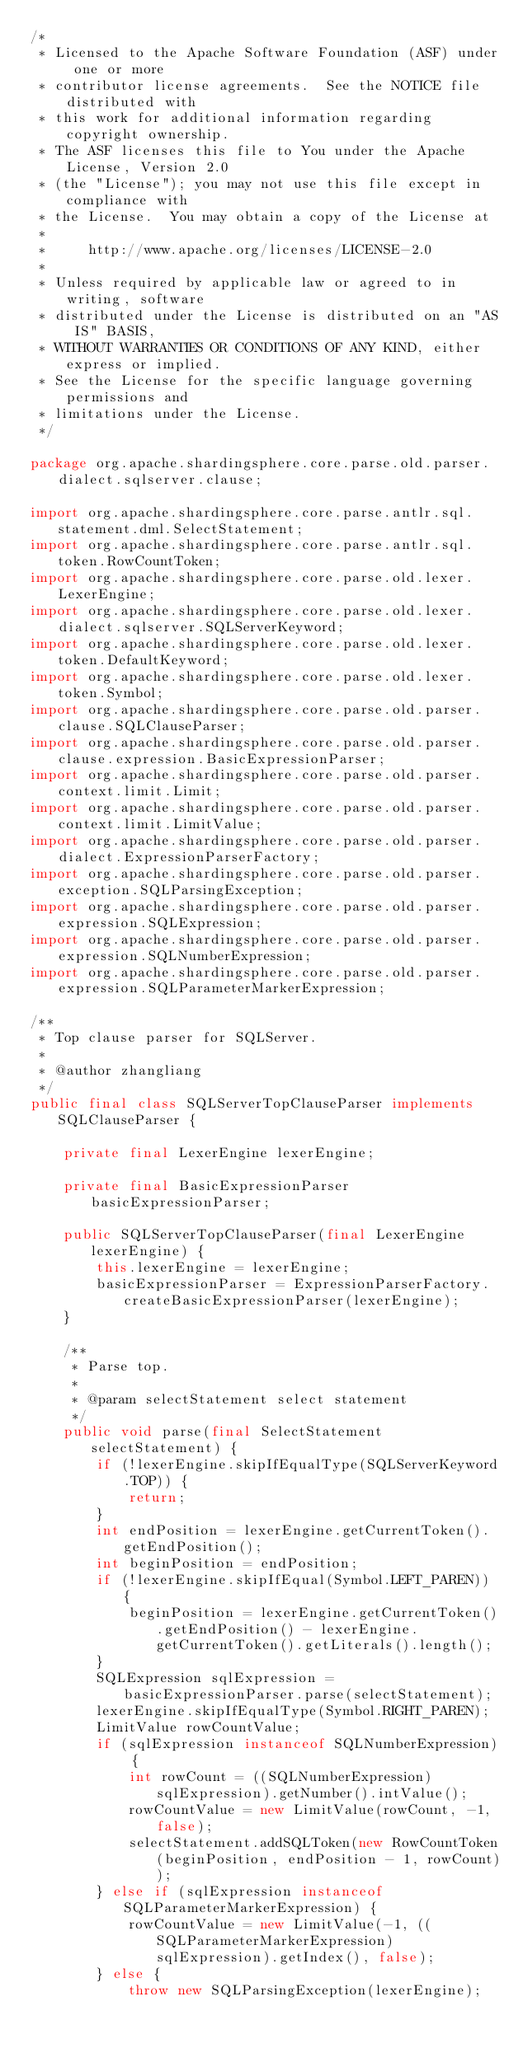Convert code to text. <code><loc_0><loc_0><loc_500><loc_500><_Java_>/*
 * Licensed to the Apache Software Foundation (ASF) under one or more
 * contributor license agreements.  See the NOTICE file distributed with
 * this work for additional information regarding copyright ownership.
 * The ASF licenses this file to You under the Apache License, Version 2.0
 * (the "License"); you may not use this file except in compliance with
 * the License.  You may obtain a copy of the License at
 *
 *     http://www.apache.org/licenses/LICENSE-2.0
 *
 * Unless required by applicable law or agreed to in writing, software
 * distributed under the License is distributed on an "AS IS" BASIS,
 * WITHOUT WARRANTIES OR CONDITIONS OF ANY KIND, either express or implied.
 * See the License for the specific language governing permissions and
 * limitations under the License.
 */

package org.apache.shardingsphere.core.parse.old.parser.dialect.sqlserver.clause;

import org.apache.shardingsphere.core.parse.antlr.sql.statement.dml.SelectStatement;
import org.apache.shardingsphere.core.parse.antlr.sql.token.RowCountToken;
import org.apache.shardingsphere.core.parse.old.lexer.LexerEngine;
import org.apache.shardingsphere.core.parse.old.lexer.dialect.sqlserver.SQLServerKeyword;
import org.apache.shardingsphere.core.parse.old.lexer.token.DefaultKeyword;
import org.apache.shardingsphere.core.parse.old.lexer.token.Symbol;
import org.apache.shardingsphere.core.parse.old.parser.clause.SQLClauseParser;
import org.apache.shardingsphere.core.parse.old.parser.clause.expression.BasicExpressionParser;
import org.apache.shardingsphere.core.parse.old.parser.context.limit.Limit;
import org.apache.shardingsphere.core.parse.old.parser.context.limit.LimitValue;
import org.apache.shardingsphere.core.parse.old.parser.dialect.ExpressionParserFactory;
import org.apache.shardingsphere.core.parse.old.parser.exception.SQLParsingException;
import org.apache.shardingsphere.core.parse.old.parser.expression.SQLExpression;
import org.apache.shardingsphere.core.parse.old.parser.expression.SQLNumberExpression;
import org.apache.shardingsphere.core.parse.old.parser.expression.SQLParameterMarkerExpression;

/**
 * Top clause parser for SQLServer.
 *
 * @author zhangliang
 */
public final class SQLServerTopClauseParser implements SQLClauseParser {
    
    private final LexerEngine lexerEngine;
    
    private final BasicExpressionParser basicExpressionParser;
    
    public SQLServerTopClauseParser(final LexerEngine lexerEngine) {
        this.lexerEngine = lexerEngine;
        basicExpressionParser = ExpressionParserFactory.createBasicExpressionParser(lexerEngine);
    }
    
    /**
     * Parse top.
     * 
     * @param selectStatement select statement
     */
    public void parse(final SelectStatement selectStatement) {
        if (!lexerEngine.skipIfEqualType(SQLServerKeyword.TOP)) {
            return;
        }
        int endPosition = lexerEngine.getCurrentToken().getEndPosition();
        int beginPosition = endPosition;
        if (!lexerEngine.skipIfEqual(Symbol.LEFT_PAREN)) {
            beginPosition = lexerEngine.getCurrentToken().getEndPosition() - lexerEngine.getCurrentToken().getLiterals().length();
        }
        SQLExpression sqlExpression = basicExpressionParser.parse(selectStatement);
        lexerEngine.skipIfEqualType(Symbol.RIGHT_PAREN);
        LimitValue rowCountValue;
        if (sqlExpression instanceof SQLNumberExpression) {
            int rowCount = ((SQLNumberExpression) sqlExpression).getNumber().intValue();
            rowCountValue = new LimitValue(rowCount, -1, false);
            selectStatement.addSQLToken(new RowCountToken(beginPosition, endPosition - 1, rowCount));
        } else if (sqlExpression instanceof SQLParameterMarkerExpression) {
            rowCountValue = new LimitValue(-1, ((SQLParameterMarkerExpression) sqlExpression).getIndex(), false);
        } else {
            throw new SQLParsingException(lexerEngine);</code> 